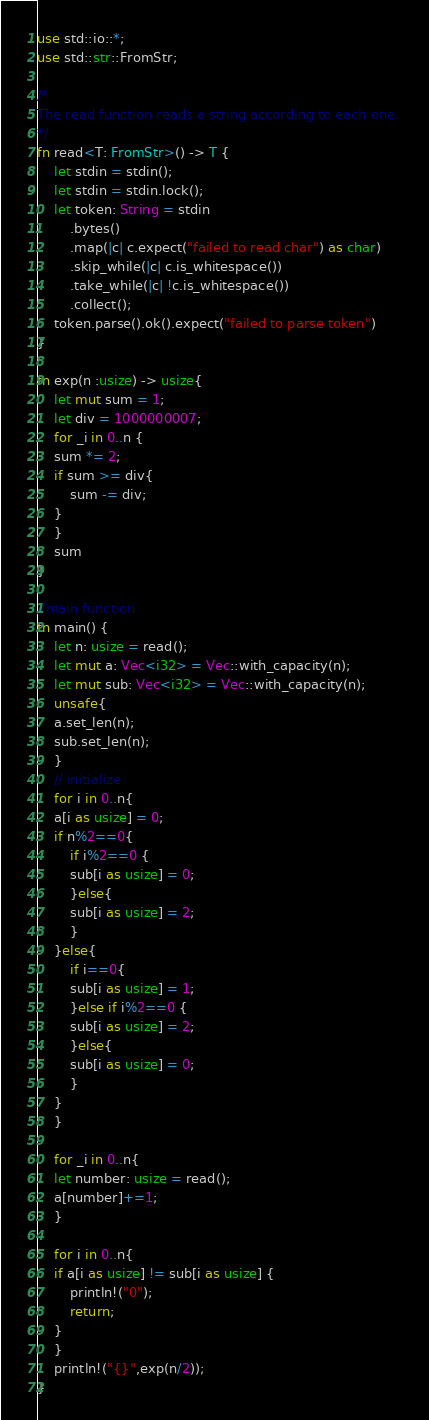<code> <loc_0><loc_0><loc_500><loc_500><_Rust_>use std::io::*;
use std::str::FromStr;

/* 
The read function reads a string according to each one. 
*/
fn read<T: FromStr>() -> T {
    let stdin = stdin();
    let stdin = stdin.lock();
    let token: String = stdin
        .bytes()
        .map(|c| c.expect("failed to read char") as char) 
        .skip_while(|c| c.is_whitespace())
        .take_while(|c| !c.is_whitespace())
        .collect();
    token.parse().ok().expect("failed to parse token")
}

fn exp(n :usize) -> usize{
    let mut sum = 1;
    let div = 1000000007;
    for _i in 0..n {
	sum *= 2;
	if sum >= div{
	    sum -= div;
	}
    }
    sum
}

//main function
fn main() {
    let n: usize = read();
    let mut a: Vec<i32> = Vec::with_capacity(n);
    let mut sub: Vec<i32> = Vec::with_capacity(n);
    unsafe{
	a.set_len(n);
	sub.set_len(n);
    }
    // initialize
    for i in 0..n{
	a[i as usize] = 0;
	if n%2==0{
	    if i%2==0 {
		sub[i as usize] = 0;
	    }else{
		sub[i as usize] = 2;
	    }
	}else{
	    if i==0{
		sub[i as usize] = 1;
	    }else if i%2==0 {
		sub[i as usize] = 2;
	    }else{
		sub[i as usize] = 0;
	    }
	}
    }

    for _i in 0..n{
	let number: usize = read();
	a[number]+=1;
    }
    
    for i in 0..n{
	if a[i as usize] != sub[i as usize] {
	    println!("0");
	    return;
	}
    }
    println!("{}",exp(n/2));
}
</code> 